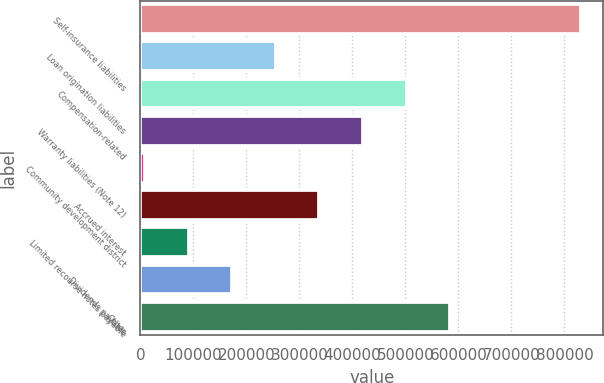Convert chart. <chart><loc_0><loc_0><loc_500><loc_500><bar_chart><fcel>Self-insurance liabilities<fcel>Loan origination liabilities<fcel>Compensation-related<fcel>Warranty liabilities (Note 12)<fcel>Community development district<fcel>Accrued interest<fcel>Limited recourse notes payable<fcel>Dividends payable<fcel>Other<nl><fcel>831058<fcel>255530<fcel>502185<fcel>419966<fcel>8875<fcel>337748<fcel>91093.3<fcel>173312<fcel>584403<nl></chart> 